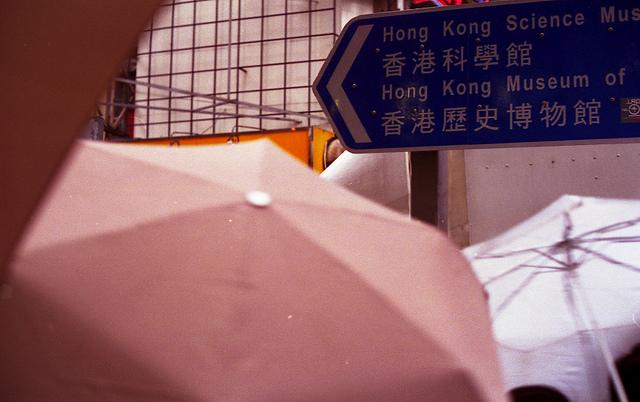How many can be seen?
Short answer required. 2. Are there umbrellas in the photo?
Concise answer only. Yes. Is the umbrella the same color?
Short answer required. No. What color is the "Hong Kong museum"?
Be succinct. White. 